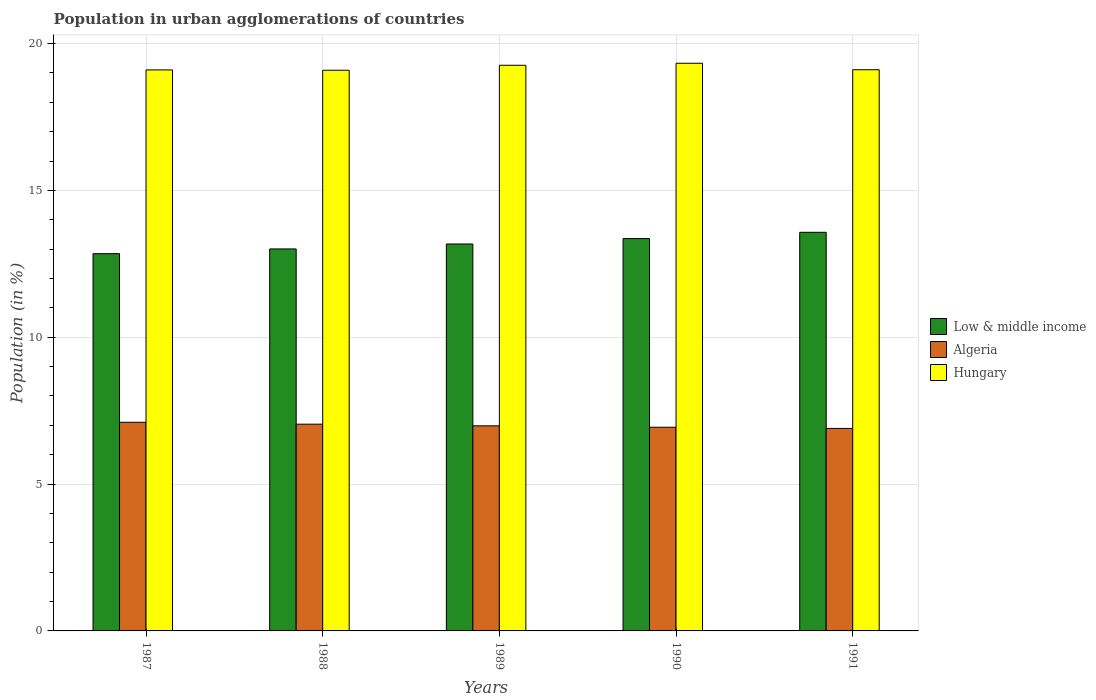How many different coloured bars are there?
Your response must be concise. 3. How many groups of bars are there?
Your answer should be compact. 5. How many bars are there on the 5th tick from the left?
Provide a succinct answer. 3. What is the label of the 2nd group of bars from the left?
Give a very brief answer. 1988. In how many cases, is the number of bars for a given year not equal to the number of legend labels?
Provide a short and direct response. 0. What is the percentage of population in urban agglomerations in Low & middle income in 1987?
Ensure brevity in your answer.  12.85. Across all years, what is the maximum percentage of population in urban agglomerations in Hungary?
Provide a succinct answer. 19.33. Across all years, what is the minimum percentage of population in urban agglomerations in Hungary?
Make the answer very short. 19.09. In which year was the percentage of population in urban agglomerations in Hungary maximum?
Offer a very short reply. 1990. What is the total percentage of population in urban agglomerations in Hungary in the graph?
Offer a terse response. 95.89. What is the difference between the percentage of population in urban agglomerations in Algeria in 1987 and that in 1989?
Offer a terse response. 0.12. What is the difference between the percentage of population in urban agglomerations in Hungary in 1987 and the percentage of population in urban agglomerations in Algeria in 1989?
Your response must be concise. 12.12. What is the average percentage of population in urban agglomerations in Low & middle income per year?
Provide a succinct answer. 13.19. In the year 1987, what is the difference between the percentage of population in urban agglomerations in Algeria and percentage of population in urban agglomerations in Hungary?
Your answer should be compact. -12. What is the ratio of the percentage of population in urban agglomerations in Low & middle income in 1987 to that in 1988?
Offer a very short reply. 0.99. Is the difference between the percentage of population in urban agglomerations in Algeria in 1988 and 1991 greater than the difference between the percentage of population in urban agglomerations in Hungary in 1988 and 1991?
Make the answer very short. Yes. What is the difference between the highest and the second highest percentage of population in urban agglomerations in Algeria?
Provide a succinct answer. 0.06. What is the difference between the highest and the lowest percentage of population in urban agglomerations in Hungary?
Offer a terse response. 0.24. What does the 3rd bar from the left in 1991 represents?
Your response must be concise. Hungary. What does the 3rd bar from the right in 1990 represents?
Offer a terse response. Low & middle income. How many bars are there?
Keep it short and to the point. 15. Are all the bars in the graph horizontal?
Provide a short and direct response. No. How many years are there in the graph?
Your answer should be compact. 5. What is the difference between two consecutive major ticks on the Y-axis?
Provide a succinct answer. 5. What is the title of the graph?
Offer a terse response. Population in urban agglomerations of countries. What is the label or title of the X-axis?
Provide a short and direct response. Years. What is the Population (in %) of Low & middle income in 1987?
Your answer should be compact. 12.85. What is the Population (in %) in Algeria in 1987?
Your answer should be very brief. 7.1. What is the Population (in %) in Hungary in 1987?
Offer a very short reply. 19.1. What is the Population (in %) of Low & middle income in 1988?
Provide a short and direct response. 13.01. What is the Population (in %) in Algeria in 1988?
Offer a terse response. 7.04. What is the Population (in %) of Hungary in 1988?
Offer a very short reply. 19.09. What is the Population (in %) in Low & middle income in 1989?
Your answer should be compact. 13.18. What is the Population (in %) of Algeria in 1989?
Offer a terse response. 6.98. What is the Population (in %) in Hungary in 1989?
Give a very brief answer. 19.26. What is the Population (in %) of Low & middle income in 1990?
Give a very brief answer. 13.36. What is the Population (in %) in Algeria in 1990?
Make the answer very short. 6.94. What is the Population (in %) in Hungary in 1990?
Your answer should be very brief. 19.33. What is the Population (in %) of Low & middle income in 1991?
Provide a short and direct response. 13.57. What is the Population (in %) in Algeria in 1991?
Ensure brevity in your answer.  6.9. What is the Population (in %) in Hungary in 1991?
Provide a succinct answer. 19.11. Across all years, what is the maximum Population (in %) of Low & middle income?
Your answer should be compact. 13.57. Across all years, what is the maximum Population (in %) in Algeria?
Your answer should be compact. 7.1. Across all years, what is the maximum Population (in %) in Hungary?
Provide a succinct answer. 19.33. Across all years, what is the minimum Population (in %) in Low & middle income?
Offer a very short reply. 12.85. Across all years, what is the minimum Population (in %) in Algeria?
Make the answer very short. 6.9. Across all years, what is the minimum Population (in %) in Hungary?
Your answer should be compact. 19.09. What is the total Population (in %) of Low & middle income in the graph?
Keep it short and to the point. 65.96. What is the total Population (in %) in Algeria in the graph?
Offer a terse response. 34.96. What is the total Population (in %) in Hungary in the graph?
Your response must be concise. 95.89. What is the difference between the Population (in %) of Low & middle income in 1987 and that in 1988?
Provide a short and direct response. -0.16. What is the difference between the Population (in %) in Algeria in 1987 and that in 1988?
Your answer should be compact. 0.06. What is the difference between the Population (in %) of Hungary in 1987 and that in 1988?
Your response must be concise. 0.01. What is the difference between the Population (in %) of Low & middle income in 1987 and that in 1989?
Provide a succinct answer. -0.33. What is the difference between the Population (in %) in Algeria in 1987 and that in 1989?
Ensure brevity in your answer.  0.12. What is the difference between the Population (in %) in Hungary in 1987 and that in 1989?
Provide a succinct answer. -0.16. What is the difference between the Population (in %) of Low & middle income in 1987 and that in 1990?
Your response must be concise. -0.51. What is the difference between the Population (in %) of Algeria in 1987 and that in 1990?
Ensure brevity in your answer.  0.17. What is the difference between the Population (in %) of Hungary in 1987 and that in 1990?
Provide a short and direct response. -0.23. What is the difference between the Population (in %) of Low & middle income in 1987 and that in 1991?
Your response must be concise. -0.73. What is the difference between the Population (in %) of Algeria in 1987 and that in 1991?
Ensure brevity in your answer.  0.21. What is the difference between the Population (in %) of Hungary in 1987 and that in 1991?
Keep it short and to the point. -0.01. What is the difference between the Population (in %) of Low & middle income in 1988 and that in 1989?
Provide a short and direct response. -0.17. What is the difference between the Population (in %) of Algeria in 1988 and that in 1989?
Provide a short and direct response. 0.06. What is the difference between the Population (in %) of Hungary in 1988 and that in 1989?
Provide a short and direct response. -0.17. What is the difference between the Population (in %) of Low & middle income in 1988 and that in 1990?
Make the answer very short. -0.35. What is the difference between the Population (in %) of Algeria in 1988 and that in 1990?
Ensure brevity in your answer.  0.1. What is the difference between the Population (in %) in Hungary in 1988 and that in 1990?
Provide a short and direct response. -0.24. What is the difference between the Population (in %) in Low & middle income in 1988 and that in 1991?
Provide a short and direct response. -0.57. What is the difference between the Population (in %) in Algeria in 1988 and that in 1991?
Offer a terse response. 0.14. What is the difference between the Population (in %) of Hungary in 1988 and that in 1991?
Keep it short and to the point. -0.02. What is the difference between the Population (in %) of Low & middle income in 1989 and that in 1990?
Give a very brief answer. -0.18. What is the difference between the Population (in %) of Algeria in 1989 and that in 1990?
Ensure brevity in your answer.  0.05. What is the difference between the Population (in %) in Hungary in 1989 and that in 1990?
Offer a terse response. -0.07. What is the difference between the Population (in %) in Low & middle income in 1989 and that in 1991?
Offer a terse response. -0.4. What is the difference between the Population (in %) of Algeria in 1989 and that in 1991?
Your response must be concise. 0.09. What is the difference between the Population (in %) in Hungary in 1989 and that in 1991?
Keep it short and to the point. 0.15. What is the difference between the Population (in %) of Low & middle income in 1990 and that in 1991?
Give a very brief answer. -0.21. What is the difference between the Population (in %) of Hungary in 1990 and that in 1991?
Provide a short and direct response. 0.22. What is the difference between the Population (in %) in Low & middle income in 1987 and the Population (in %) in Algeria in 1988?
Offer a very short reply. 5.81. What is the difference between the Population (in %) of Low & middle income in 1987 and the Population (in %) of Hungary in 1988?
Give a very brief answer. -6.25. What is the difference between the Population (in %) of Algeria in 1987 and the Population (in %) of Hungary in 1988?
Ensure brevity in your answer.  -11.99. What is the difference between the Population (in %) in Low & middle income in 1987 and the Population (in %) in Algeria in 1989?
Give a very brief answer. 5.86. What is the difference between the Population (in %) in Low & middle income in 1987 and the Population (in %) in Hungary in 1989?
Make the answer very short. -6.41. What is the difference between the Population (in %) of Algeria in 1987 and the Population (in %) of Hungary in 1989?
Ensure brevity in your answer.  -12.16. What is the difference between the Population (in %) in Low & middle income in 1987 and the Population (in %) in Algeria in 1990?
Ensure brevity in your answer.  5.91. What is the difference between the Population (in %) in Low & middle income in 1987 and the Population (in %) in Hungary in 1990?
Your answer should be compact. -6.48. What is the difference between the Population (in %) of Algeria in 1987 and the Population (in %) of Hungary in 1990?
Offer a terse response. -12.23. What is the difference between the Population (in %) of Low & middle income in 1987 and the Population (in %) of Algeria in 1991?
Provide a short and direct response. 5.95. What is the difference between the Population (in %) in Low & middle income in 1987 and the Population (in %) in Hungary in 1991?
Ensure brevity in your answer.  -6.26. What is the difference between the Population (in %) in Algeria in 1987 and the Population (in %) in Hungary in 1991?
Make the answer very short. -12.01. What is the difference between the Population (in %) of Low & middle income in 1988 and the Population (in %) of Algeria in 1989?
Keep it short and to the point. 6.02. What is the difference between the Population (in %) of Low & middle income in 1988 and the Population (in %) of Hungary in 1989?
Make the answer very short. -6.25. What is the difference between the Population (in %) in Algeria in 1988 and the Population (in %) in Hungary in 1989?
Keep it short and to the point. -12.22. What is the difference between the Population (in %) in Low & middle income in 1988 and the Population (in %) in Algeria in 1990?
Offer a terse response. 6.07. What is the difference between the Population (in %) of Low & middle income in 1988 and the Population (in %) of Hungary in 1990?
Provide a succinct answer. -6.32. What is the difference between the Population (in %) of Algeria in 1988 and the Population (in %) of Hungary in 1990?
Offer a very short reply. -12.29. What is the difference between the Population (in %) of Low & middle income in 1988 and the Population (in %) of Algeria in 1991?
Your answer should be compact. 6.11. What is the difference between the Population (in %) in Low & middle income in 1988 and the Population (in %) in Hungary in 1991?
Give a very brief answer. -6.1. What is the difference between the Population (in %) in Algeria in 1988 and the Population (in %) in Hungary in 1991?
Ensure brevity in your answer.  -12.07. What is the difference between the Population (in %) in Low & middle income in 1989 and the Population (in %) in Algeria in 1990?
Offer a very short reply. 6.24. What is the difference between the Population (in %) in Low & middle income in 1989 and the Population (in %) in Hungary in 1990?
Your answer should be compact. -6.15. What is the difference between the Population (in %) of Algeria in 1989 and the Population (in %) of Hungary in 1990?
Provide a short and direct response. -12.35. What is the difference between the Population (in %) in Low & middle income in 1989 and the Population (in %) in Algeria in 1991?
Provide a short and direct response. 6.28. What is the difference between the Population (in %) in Low & middle income in 1989 and the Population (in %) in Hungary in 1991?
Offer a terse response. -5.93. What is the difference between the Population (in %) of Algeria in 1989 and the Population (in %) of Hungary in 1991?
Provide a short and direct response. -12.13. What is the difference between the Population (in %) of Low & middle income in 1990 and the Population (in %) of Algeria in 1991?
Make the answer very short. 6.46. What is the difference between the Population (in %) in Low & middle income in 1990 and the Population (in %) in Hungary in 1991?
Your answer should be compact. -5.75. What is the difference between the Population (in %) of Algeria in 1990 and the Population (in %) of Hungary in 1991?
Make the answer very short. -12.17. What is the average Population (in %) of Low & middle income per year?
Your response must be concise. 13.19. What is the average Population (in %) in Algeria per year?
Keep it short and to the point. 6.99. What is the average Population (in %) in Hungary per year?
Provide a succinct answer. 19.18. In the year 1987, what is the difference between the Population (in %) in Low & middle income and Population (in %) in Algeria?
Your answer should be compact. 5.74. In the year 1987, what is the difference between the Population (in %) of Low & middle income and Population (in %) of Hungary?
Keep it short and to the point. -6.26. In the year 1987, what is the difference between the Population (in %) in Algeria and Population (in %) in Hungary?
Your answer should be very brief. -12. In the year 1988, what is the difference between the Population (in %) in Low & middle income and Population (in %) in Algeria?
Offer a very short reply. 5.97. In the year 1988, what is the difference between the Population (in %) of Low & middle income and Population (in %) of Hungary?
Provide a short and direct response. -6.08. In the year 1988, what is the difference between the Population (in %) in Algeria and Population (in %) in Hungary?
Offer a very short reply. -12.05. In the year 1989, what is the difference between the Population (in %) of Low & middle income and Population (in %) of Algeria?
Your answer should be very brief. 6.19. In the year 1989, what is the difference between the Population (in %) in Low & middle income and Population (in %) in Hungary?
Your response must be concise. -6.08. In the year 1989, what is the difference between the Population (in %) in Algeria and Population (in %) in Hungary?
Offer a very short reply. -12.28. In the year 1990, what is the difference between the Population (in %) in Low & middle income and Population (in %) in Algeria?
Give a very brief answer. 6.42. In the year 1990, what is the difference between the Population (in %) of Low & middle income and Population (in %) of Hungary?
Offer a very short reply. -5.97. In the year 1990, what is the difference between the Population (in %) in Algeria and Population (in %) in Hungary?
Provide a succinct answer. -12.39. In the year 1991, what is the difference between the Population (in %) of Low & middle income and Population (in %) of Algeria?
Your response must be concise. 6.68. In the year 1991, what is the difference between the Population (in %) of Low & middle income and Population (in %) of Hungary?
Your response must be concise. -5.54. In the year 1991, what is the difference between the Population (in %) in Algeria and Population (in %) in Hungary?
Provide a succinct answer. -12.21. What is the ratio of the Population (in %) of Algeria in 1987 to that in 1988?
Keep it short and to the point. 1.01. What is the ratio of the Population (in %) in Low & middle income in 1987 to that in 1989?
Ensure brevity in your answer.  0.97. What is the ratio of the Population (in %) of Algeria in 1987 to that in 1989?
Your answer should be very brief. 1.02. What is the ratio of the Population (in %) of Hungary in 1987 to that in 1989?
Offer a terse response. 0.99. What is the ratio of the Population (in %) in Low & middle income in 1987 to that in 1990?
Keep it short and to the point. 0.96. What is the ratio of the Population (in %) in Algeria in 1987 to that in 1990?
Give a very brief answer. 1.02. What is the ratio of the Population (in %) in Hungary in 1987 to that in 1990?
Keep it short and to the point. 0.99. What is the ratio of the Population (in %) of Low & middle income in 1987 to that in 1991?
Offer a terse response. 0.95. What is the ratio of the Population (in %) of Algeria in 1987 to that in 1991?
Provide a succinct answer. 1.03. What is the ratio of the Population (in %) in Hungary in 1987 to that in 1991?
Provide a succinct answer. 1. What is the ratio of the Population (in %) in Low & middle income in 1988 to that in 1989?
Provide a short and direct response. 0.99. What is the ratio of the Population (in %) in Low & middle income in 1988 to that in 1990?
Provide a succinct answer. 0.97. What is the ratio of the Population (in %) of Algeria in 1988 to that in 1990?
Ensure brevity in your answer.  1.02. What is the ratio of the Population (in %) of Hungary in 1988 to that in 1990?
Provide a succinct answer. 0.99. What is the ratio of the Population (in %) in Low & middle income in 1988 to that in 1991?
Your answer should be very brief. 0.96. What is the ratio of the Population (in %) in Algeria in 1988 to that in 1991?
Offer a very short reply. 1.02. What is the ratio of the Population (in %) in Low & middle income in 1989 to that in 1990?
Offer a very short reply. 0.99. What is the ratio of the Population (in %) in Hungary in 1989 to that in 1990?
Make the answer very short. 1. What is the ratio of the Population (in %) of Low & middle income in 1989 to that in 1991?
Give a very brief answer. 0.97. What is the ratio of the Population (in %) of Algeria in 1989 to that in 1991?
Provide a short and direct response. 1.01. What is the ratio of the Population (in %) in Hungary in 1989 to that in 1991?
Offer a terse response. 1.01. What is the ratio of the Population (in %) of Low & middle income in 1990 to that in 1991?
Provide a short and direct response. 0.98. What is the ratio of the Population (in %) of Hungary in 1990 to that in 1991?
Make the answer very short. 1.01. What is the difference between the highest and the second highest Population (in %) of Low & middle income?
Offer a terse response. 0.21. What is the difference between the highest and the second highest Population (in %) of Algeria?
Make the answer very short. 0.06. What is the difference between the highest and the second highest Population (in %) of Hungary?
Your answer should be compact. 0.07. What is the difference between the highest and the lowest Population (in %) of Low & middle income?
Make the answer very short. 0.73. What is the difference between the highest and the lowest Population (in %) in Algeria?
Offer a terse response. 0.21. What is the difference between the highest and the lowest Population (in %) of Hungary?
Provide a short and direct response. 0.24. 